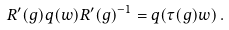<formula> <loc_0><loc_0><loc_500><loc_500>R ^ { \prime } ( g ) q ( w ) R ^ { \prime } ( g ) ^ { - 1 } = q ( \tau ( g ) w ) \, .</formula> 